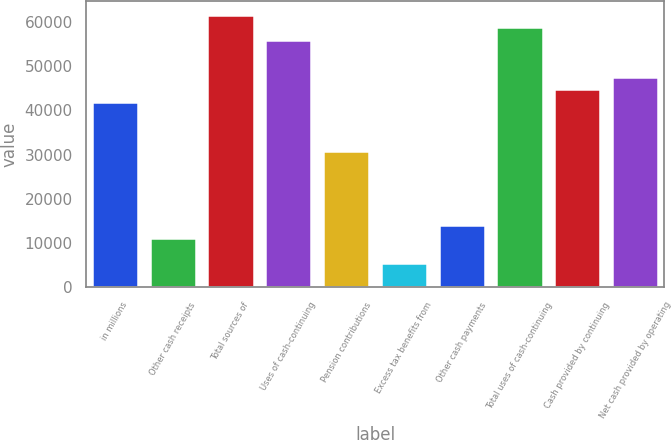Convert chart. <chart><loc_0><loc_0><loc_500><loc_500><bar_chart><fcel>in millions<fcel>Other cash receipts<fcel>Total sources of<fcel>Uses of cash-continuing<fcel>Pension contributions<fcel>Excess tax benefits from<fcel>Other cash payments<fcel>Total uses of cash-continuing<fcel>Cash provided by continuing<fcel>Net cash provided by operating<nl><fcel>42011<fcel>11204.4<fcel>61615.2<fcel>56014<fcel>30808.6<fcel>5603.2<fcel>14005<fcel>58814.6<fcel>44811.6<fcel>47612.2<nl></chart> 